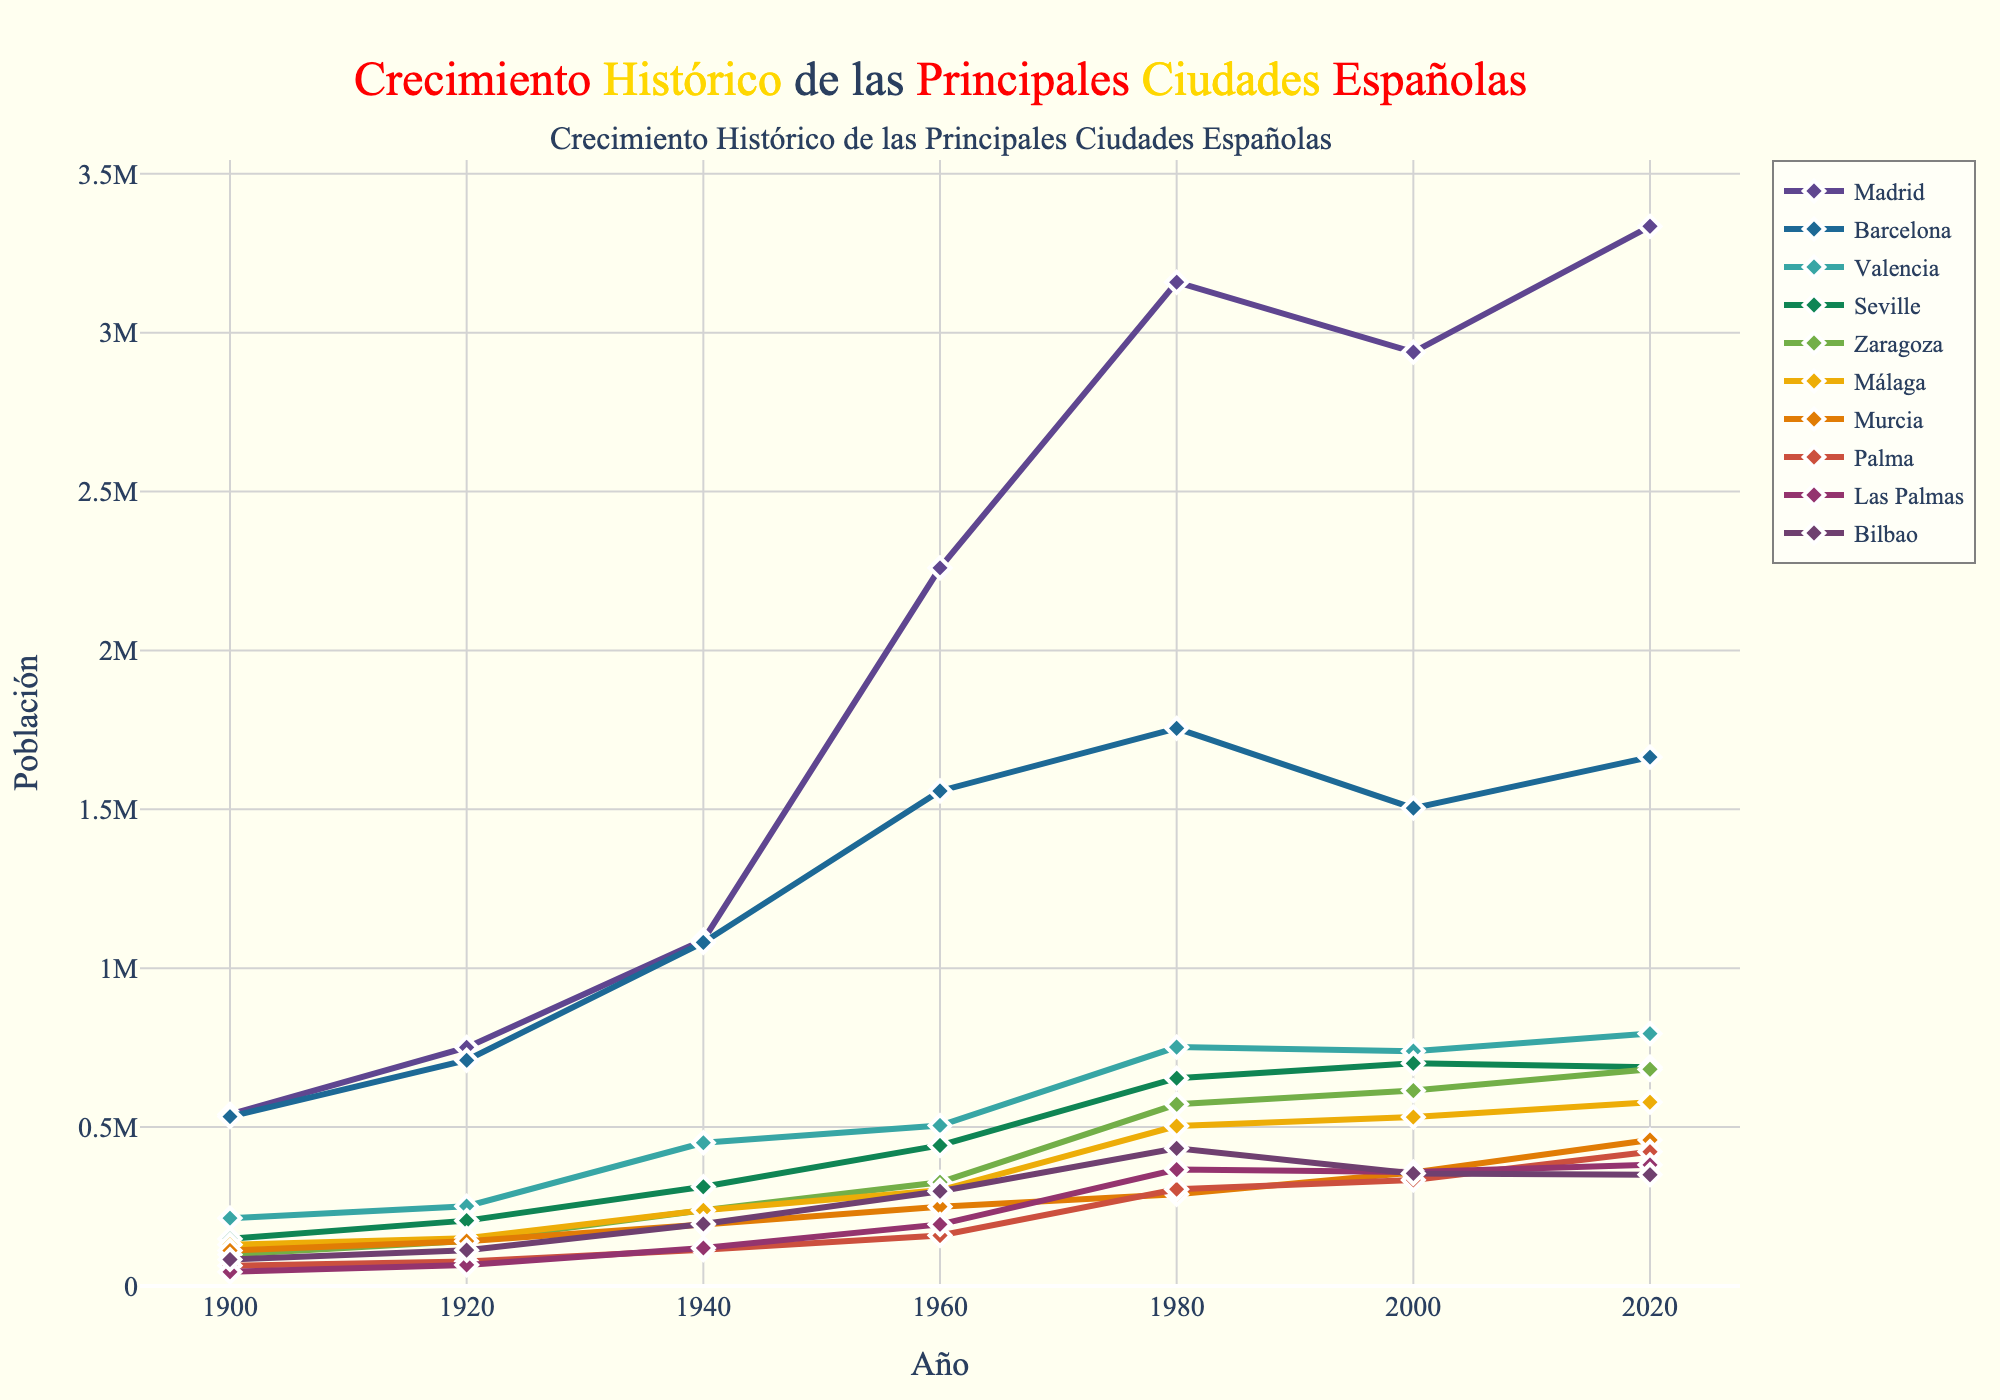What's the overall trend in population growth for Madrid from 1900 to 2020? The population of Madrid consistently increases from 1900 to 2020, with notable growth during the 20th century. The population starts at 539,835 in 1900 and increases to 3,334,730 by 2020, showing a steady upward trend.
Answer: Steady upward trend Which city has the highest population in 2020? By referring to the endpoints of the lines in 2020, Madrid has the highest population of 3,334,730 compared to other cities.
Answer: Madrid Compare the populations of Valencia and Seville in the year 2000. Which one had a higher population and by how much? From the figure, Valencia had a population of 739,014 and Seville had 700,716 in 2000. Comparing these values, Valencia's population was higher by 739,014 - 700,716 = 38,298.
Answer: Valencia, by 38,298 Which city had the smallest population in 1900 and how much was it? Comparing the initial values in 1900, Las Palmas had the smallest population with 44,517.
Answer: Las Palmas, 44,517 What visual cues help identify the steady population growth of Barcelona over the years? The line representing Barcelona shows consistent upward movement from 1900 to 1980, with a slight dip around 2000 and then an increase again towards 2020. The line is marked with blue color and diamond symbols.
Answer: Consistent upward line with slight dip, blue and diamond symbols Calculate the difference in population growth between Málaga and Zaragoza from 1900 to 2020. For Málaga: 578,460 - 130,109 = 448,351; For Zaragoza: 681,877 - 99,118 = 582,759; The difference is 582,759 - 448,351 = 134,408 more in Zaragoza.
Answer: 134,408 more in Zaragoza Which two cities showed a decreasing population between 1980 and 2000, and by how much did their populations drop? Looking at the lines between 1980 and 2000, both Barcelona (1,754,900 to 1,503,884) and Bilbao (433,115 to 354,271) show drops. For Barcelona: 1,754,900 - 1,503,884 = 251,016; For Bilbao: 433,115 - 354,271 = 78,844.
Answer: Barcelona by 251,016, Bilbao by 78,844 Identify the trend in population growth for Murcia from 1960 to 2020. Murcia shows a steady increase in population from 249,738 in 1960 to 459,403 in 2020, indicating continuous growth.
Answer: Continuous growth Which city had the largest increase in population between 1960 and 1980, and what was the value of the increase? From the 1960 and 1980 data points, Madrid has the largest increase: 3,158,818 - 2,259,931 = 898,887.
Answer: Madrid, 898,887 What is the average population of Bilbao across the seven time points shown? Sum the populations: 83,306 + 112,819 + 195,186 + 297,942 + 433,115 + 354,271 + 350,184 = 1,826,823; Average = 1,826,823 / 7 = 260,975
Answer: 260,975 